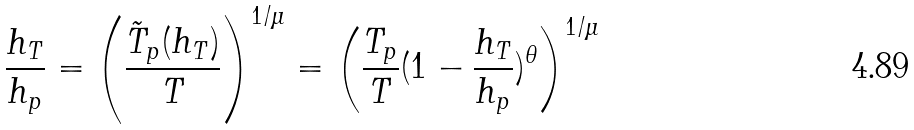<formula> <loc_0><loc_0><loc_500><loc_500>\frac { h _ { T } } { h _ { p } } = \left ( \frac { \tilde { T } _ { p } ( h _ { T } ) } { T } \right ) ^ { 1 / \mu } = \left ( \frac { T _ { p } } { T } ( 1 - \frac { h _ { T } } { h _ { p } } ) ^ { \theta } \right ) ^ { 1 / \mu } \,</formula> 